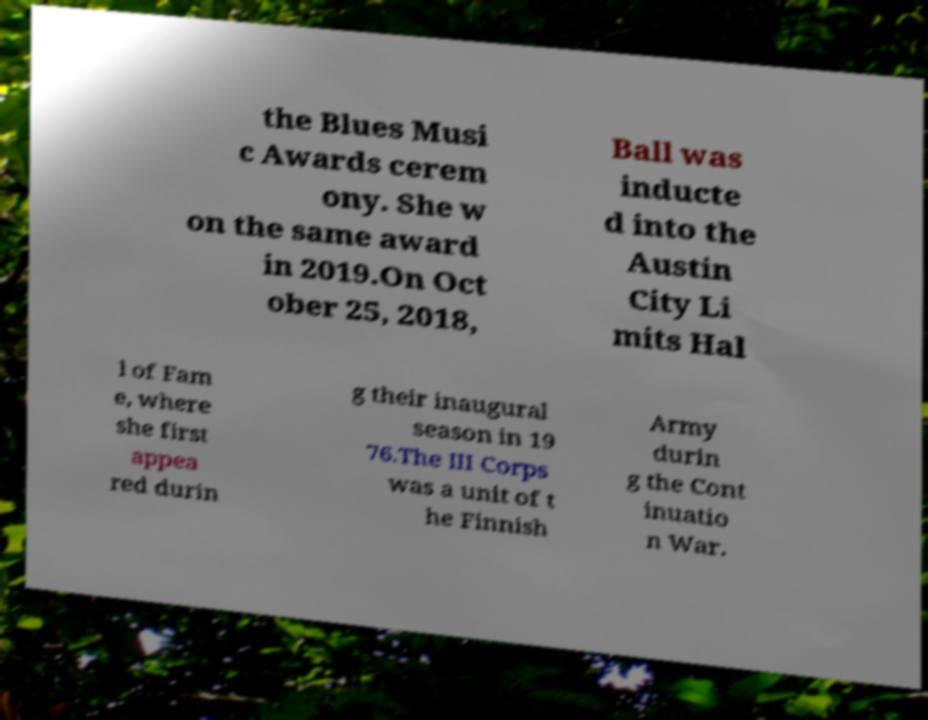There's text embedded in this image that I need extracted. Can you transcribe it verbatim? the Blues Musi c Awards cerem ony. She w on the same award in 2019.On Oct ober 25, 2018, Ball was inducte d into the Austin City Li mits Hal l of Fam e, where she first appea red durin g their inaugural season in 19 76.The III Corps was a unit of t he Finnish Army durin g the Cont inuatio n War. 